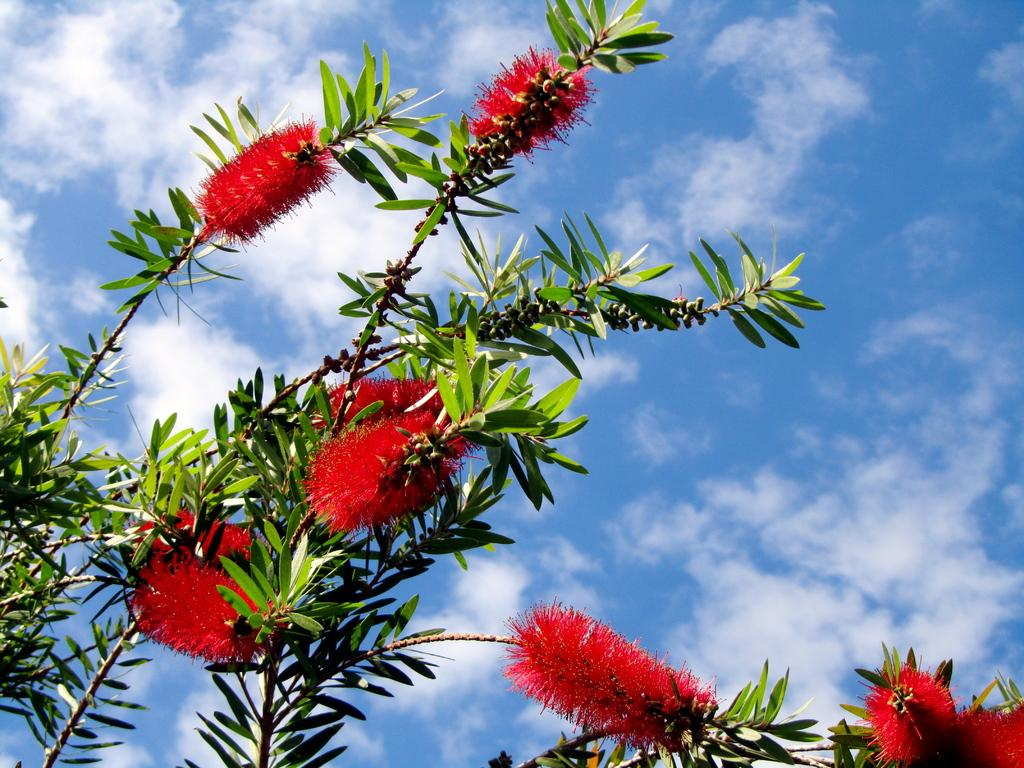What type of plants are on the left side of the image? There are plants with flowers and leaves on the left side of the image. What can be seen in the background of the image? There are clouds in the blue sky in the background of the image. What type of sound can be heard coming from the tree in the image? There is no tree present in the image, and therefore no sound can be heard coming from it. 